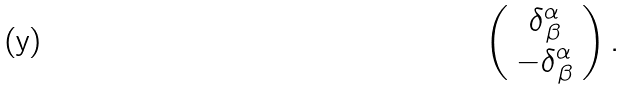Convert formula to latex. <formula><loc_0><loc_0><loc_500><loc_500>\left ( \begin{array} { c } \delta _ { \, \beta } ^ { \alpha } \\ - \delta _ { \, \beta } ^ { \alpha } \end{array} \right ) .</formula> 